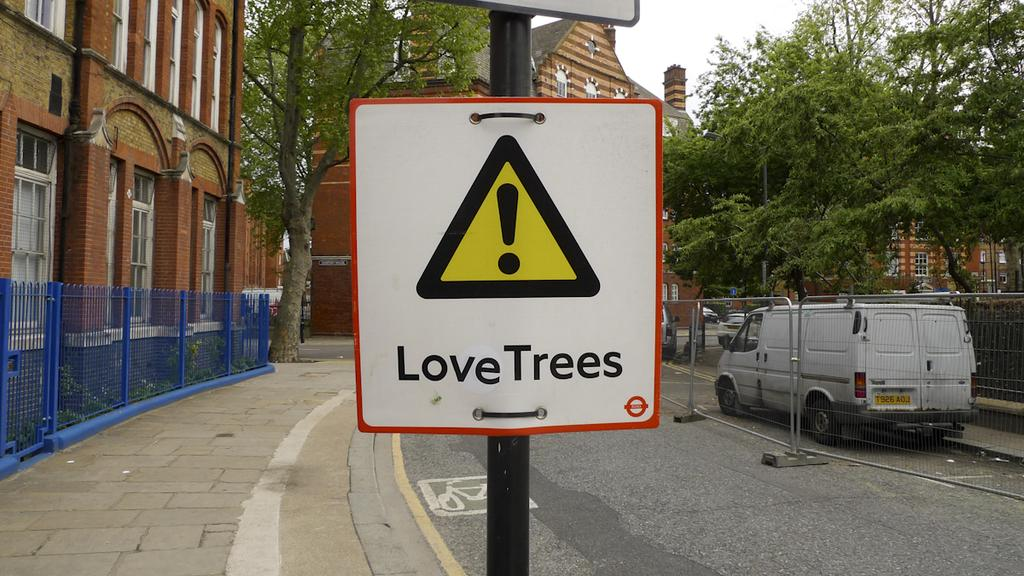Provide a one-sentence caption for the provided image. A white and red bordered sign reads Love trees on it. 